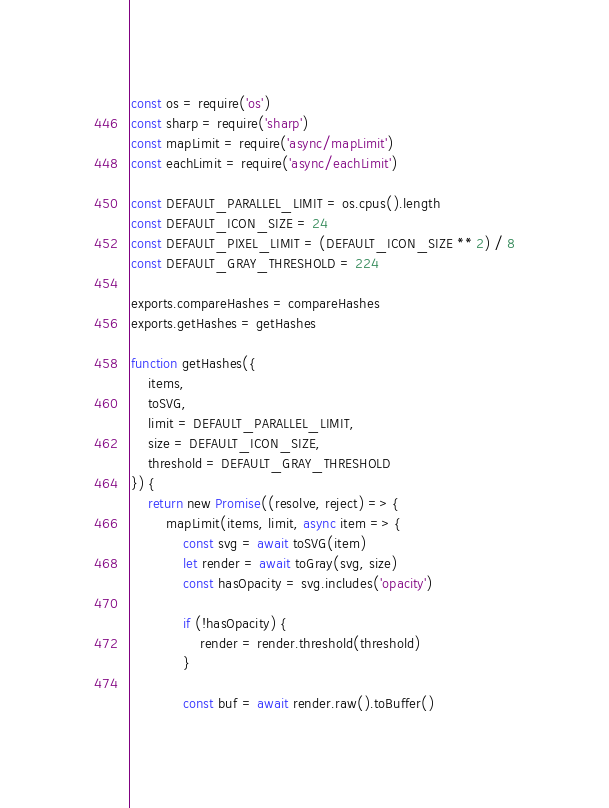Convert code to text. <code><loc_0><loc_0><loc_500><loc_500><_JavaScript_>const os = require('os')
const sharp = require('sharp')
const mapLimit = require('async/mapLimit')
const eachLimit = require('async/eachLimit')

const DEFAULT_PARALLEL_LIMIT = os.cpus().length
const DEFAULT_ICON_SIZE = 24
const DEFAULT_PIXEL_LIMIT = (DEFAULT_ICON_SIZE ** 2) / 8
const DEFAULT_GRAY_THRESHOLD = 224

exports.compareHashes = compareHashes
exports.getHashes = getHashes

function getHashes({
	items,
	toSVG,
	limit = DEFAULT_PARALLEL_LIMIT,
	size = DEFAULT_ICON_SIZE,
	threshold = DEFAULT_GRAY_THRESHOLD
}) {
	return new Promise((resolve, reject) => {
		mapLimit(items, limit, async item => {
			const svg = await toSVG(item)
			let render = await toGray(svg, size)
			const hasOpacity = svg.includes('opacity')

			if (!hasOpacity) {
				render = render.threshold(threshold)
			}

			const buf = await render.raw().toBuffer()</code> 